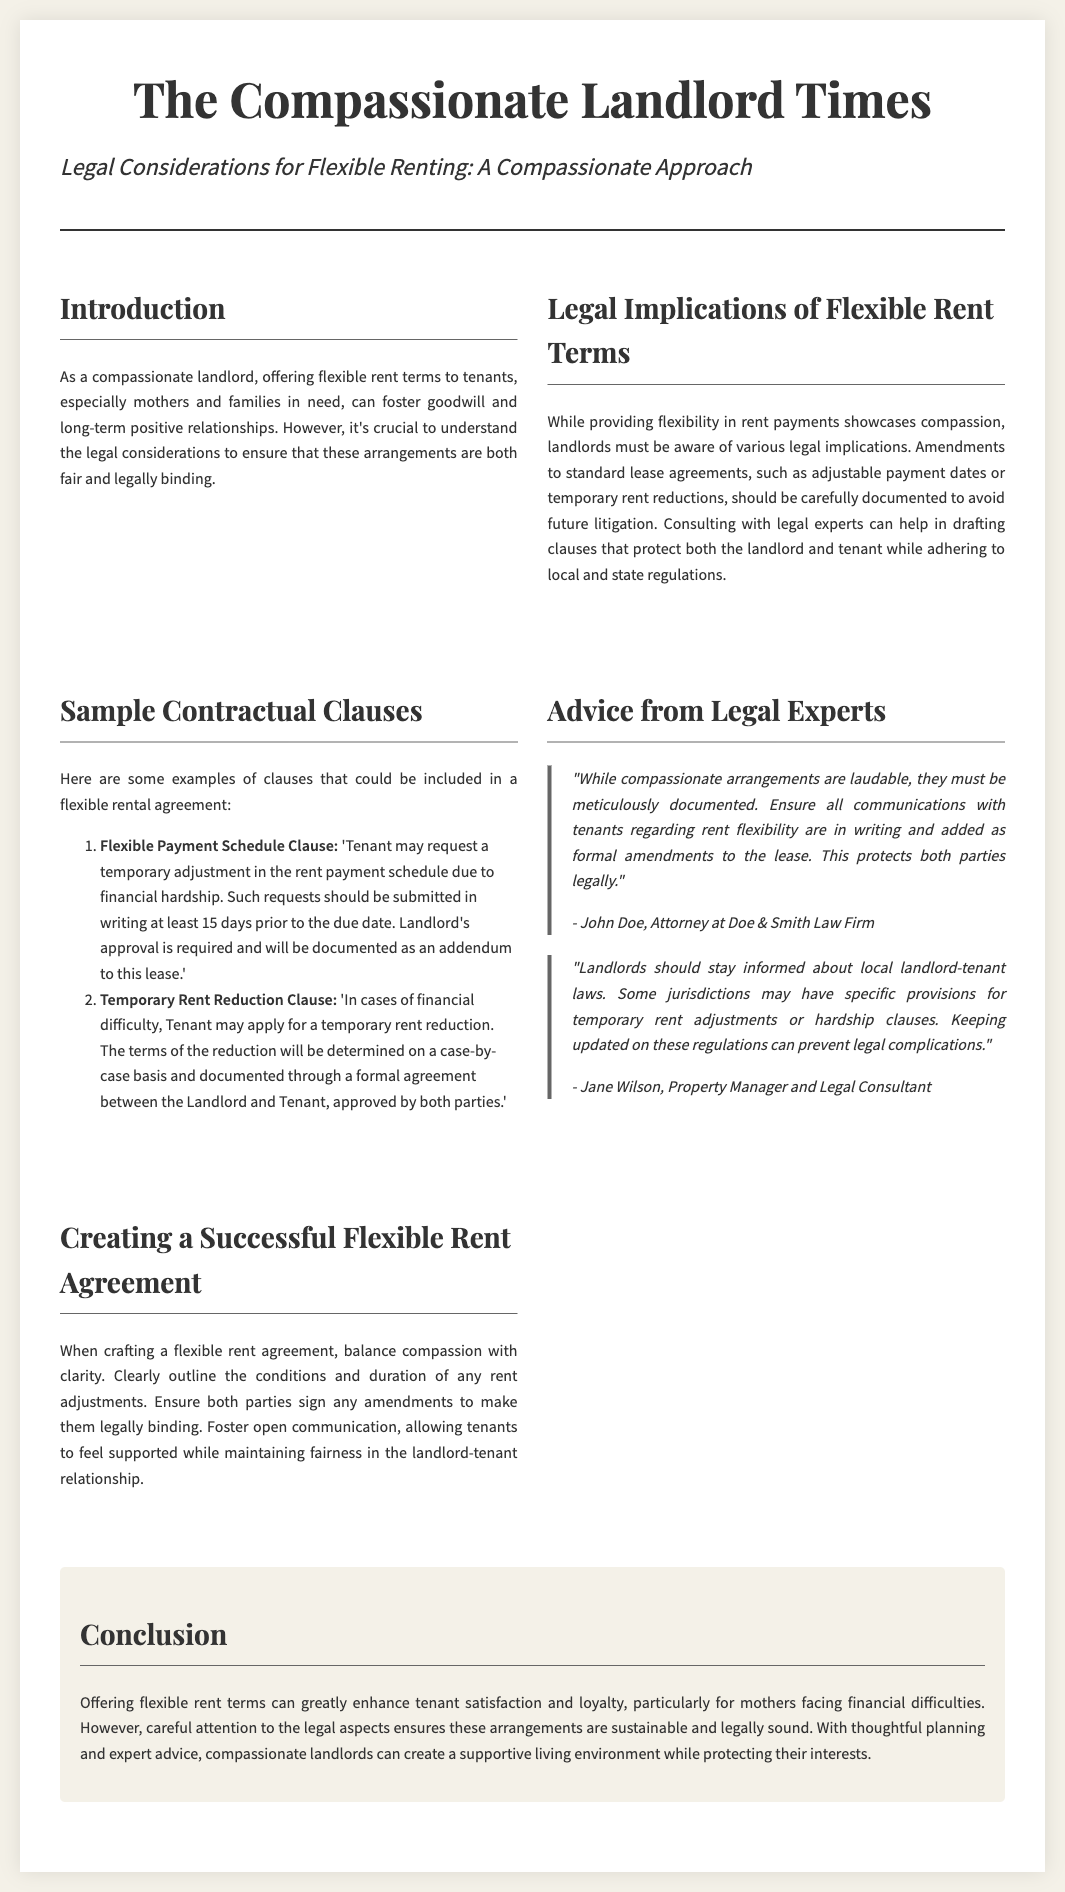What is the title of the document? The title is prominently displayed at the top of the document, indicating the subject matter of the content.
Answer: The Compassionate Landlord Times Who is quoted regarding the importance of documentation? John Doe emphasizes the need for meticulous documentation in the context of flexible rent arrangements.
Answer: John Doe What is the primary focus of the advice from legal experts section? The section provides insights on ensuring legal protection while being compassionate towards tenants.
Answer: Documentation How many days prior to the due date should a tenant submit a request for a temporary adjustment in the rent payment schedule? The document mentions a specific timeframe for tenants to submit such requests, which is stated clearly.
Answer: 15 days What should landlords stay informed about according to the legal consultant? This advice is targeted towards helping landlords avoid legal complications within their rental agreements.
Answer: Local landlord-tenant laws What is one component that should be included in a flexible rent agreement? This component is critical for establishing clarity and maintaining a fair relationship between landlords and tenants.
Answer: Conditions and duration What is the overall implication of offering flexible rent terms stated in the conclusion? The conclusion summarizes the benefits to both tenants and landlords from the discussed approach.
Answer: Enhanced tenant satisfaction and loyalty 